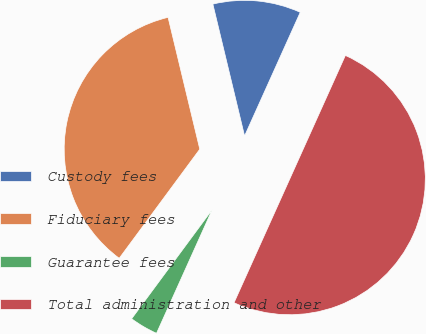Convert chart. <chart><loc_0><loc_0><loc_500><loc_500><pie_chart><fcel>Custody fees<fcel>Fiduciary fees<fcel>Guarantee fees<fcel>Total administration and other<nl><fcel>10.49%<fcel>36.12%<fcel>3.39%<fcel>50.0%<nl></chart> 